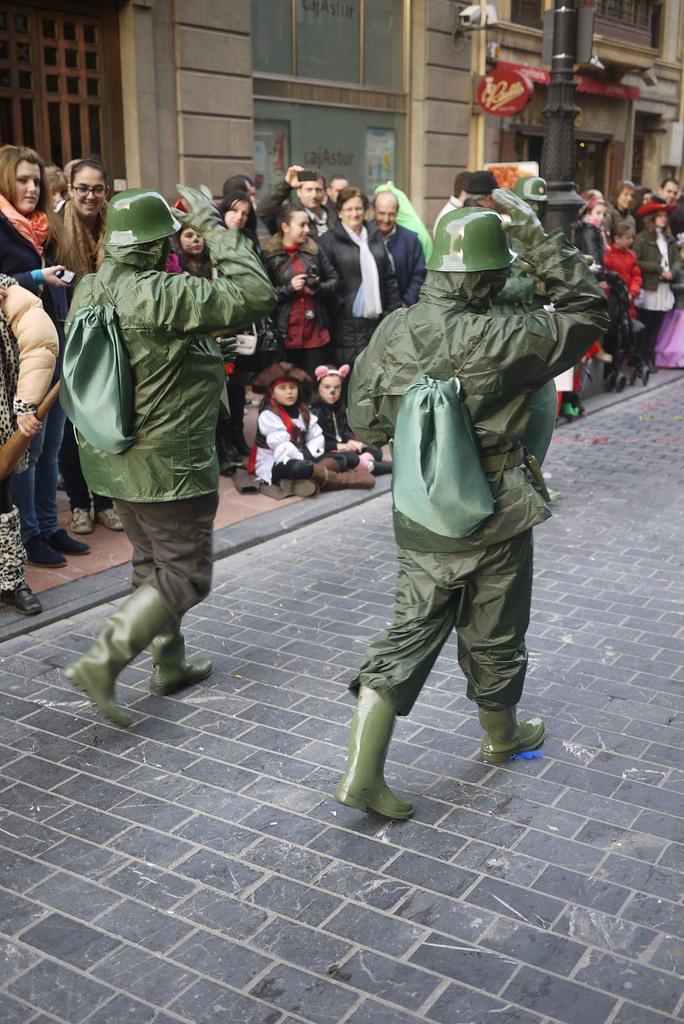Describe this image in one or two sentences. In this picture we can observe two members walking in this path, wearing green color dresses, bags and helmets on their heads. We can observe some people standing on the footpath. In the background there is a building. 